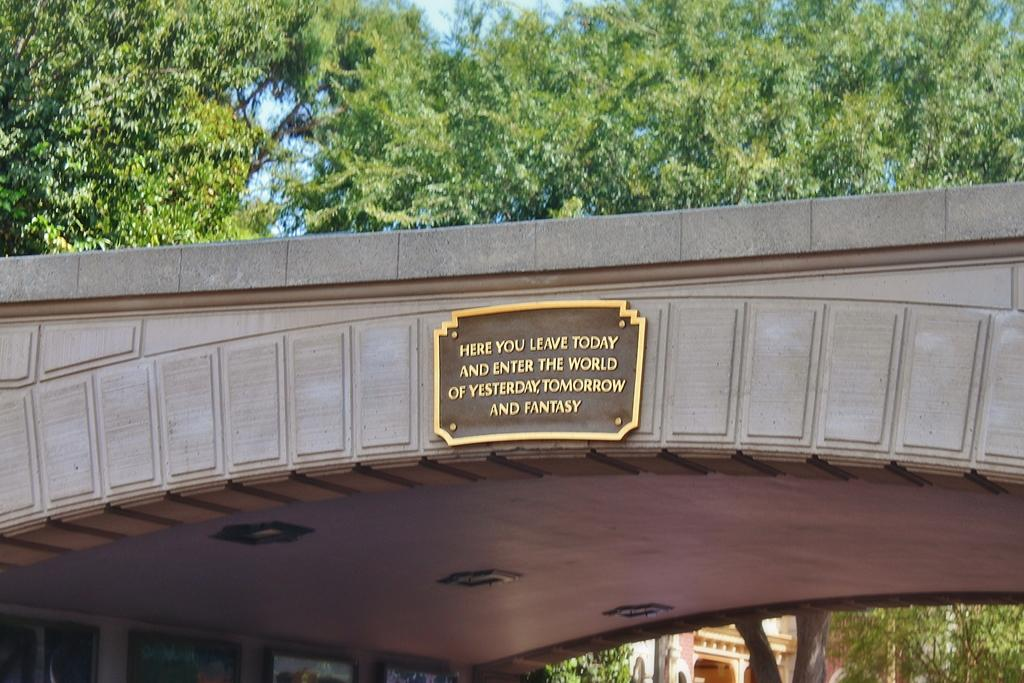<image>
Present a compact description of the photo's key features. A plaque on a bridge informs visitors they are entering a world of fantasy. 